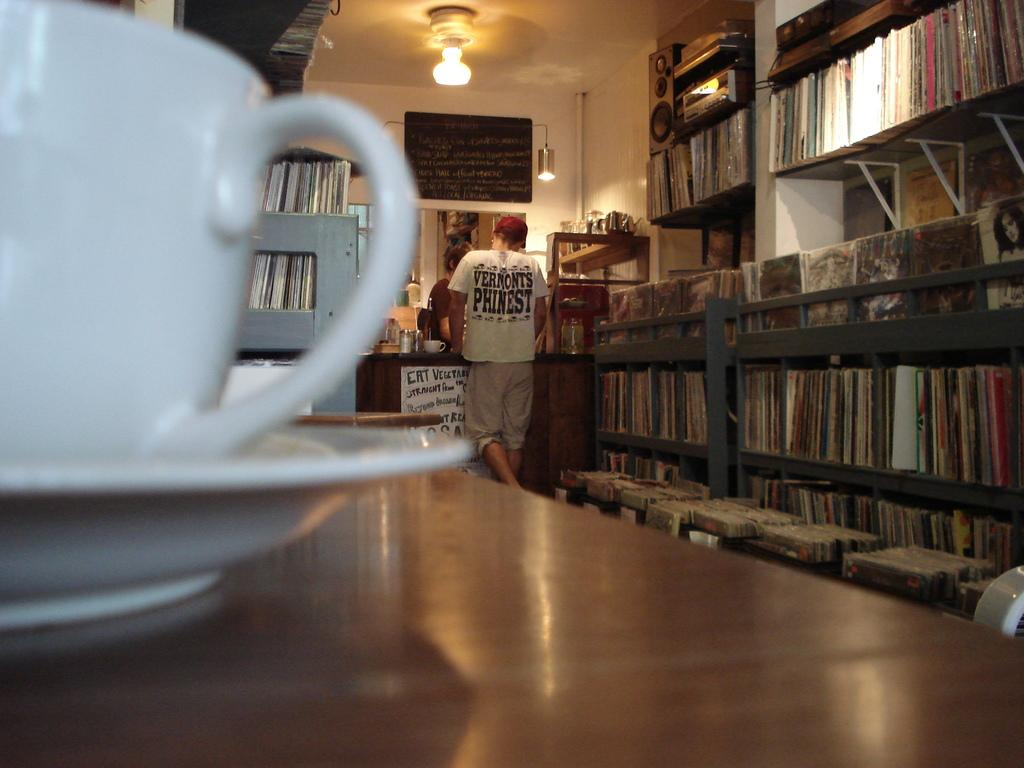Provide a one-sentence caption for the provided image. A far away shot of a man at a checkout counter with a sign that says "Eat Vegetables" on it. 